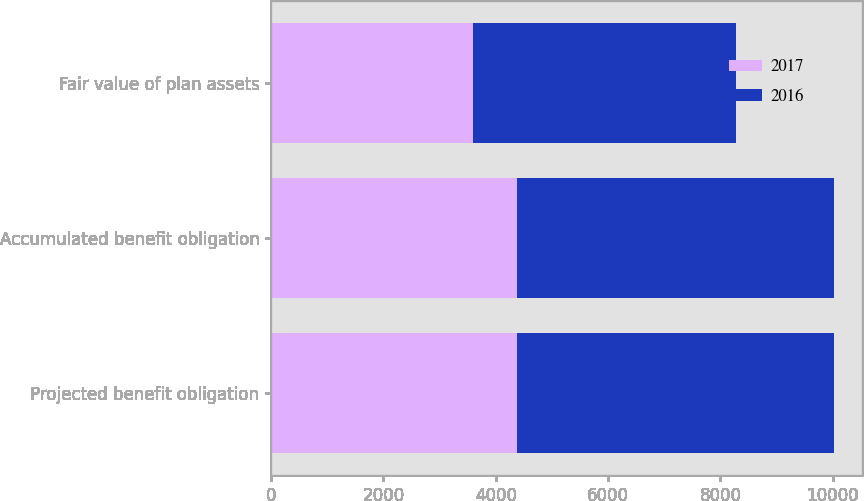<chart> <loc_0><loc_0><loc_500><loc_500><stacked_bar_chart><ecel><fcel>Projected benefit obligation<fcel>Accumulated benefit obligation<fcel>Fair value of plan assets<nl><fcel>2017<fcel>4376<fcel>4376<fcel>3592<nl><fcel>2016<fcel>5650<fcel>5650<fcel>4678<nl></chart> 